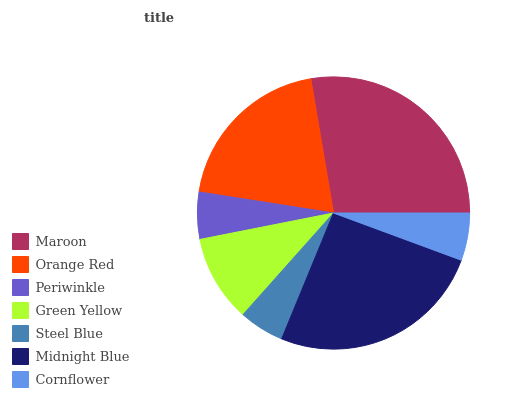Is Steel Blue the minimum?
Answer yes or no. Yes. Is Maroon the maximum?
Answer yes or no. Yes. Is Orange Red the minimum?
Answer yes or no. No. Is Orange Red the maximum?
Answer yes or no. No. Is Maroon greater than Orange Red?
Answer yes or no. Yes. Is Orange Red less than Maroon?
Answer yes or no. Yes. Is Orange Red greater than Maroon?
Answer yes or no. No. Is Maroon less than Orange Red?
Answer yes or no. No. Is Green Yellow the high median?
Answer yes or no. Yes. Is Green Yellow the low median?
Answer yes or no. Yes. Is Midnight Blue the high median?
Answer yes or no. No. Is Cornflower the low median?
Answer yes or no. No. 